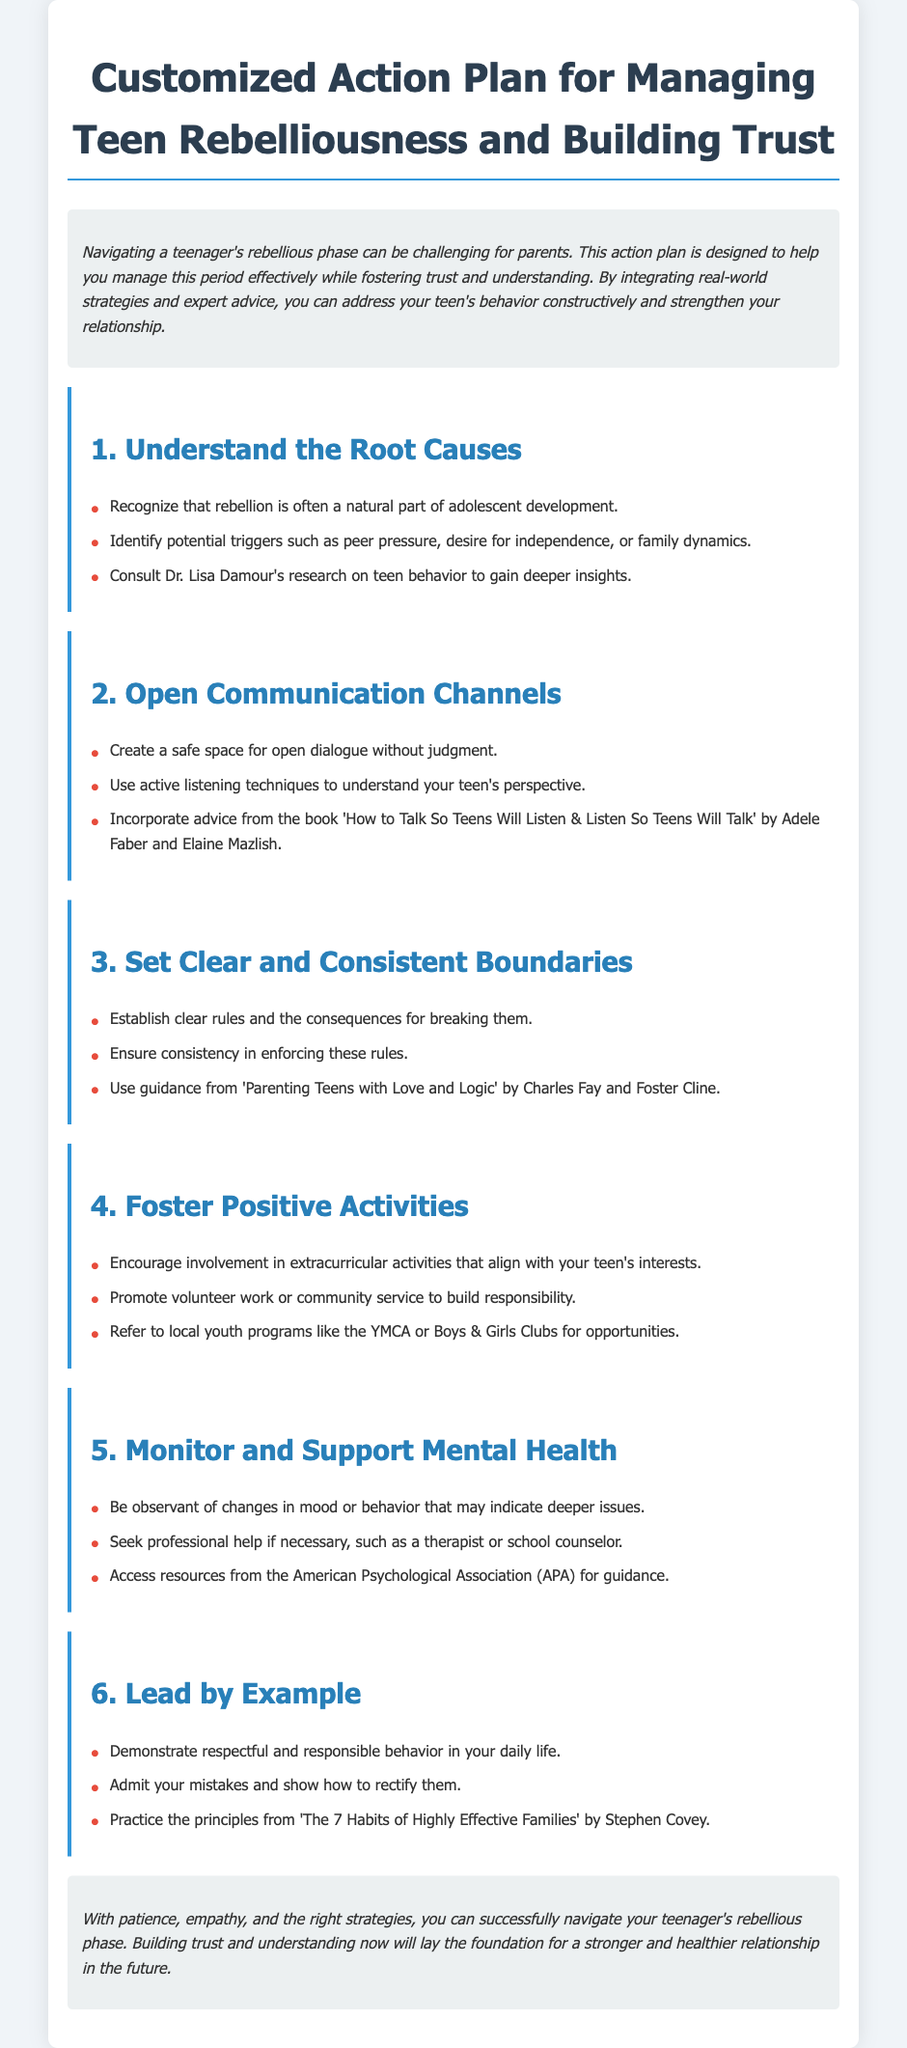What is the title of the document? The title is the heading of the document, which clearly states the main focus of the content.
Answer: Customized Action Plan for Managing Teen Rebelliousness and Building Trust Who is referenced for insight into teen behavior? This question refers to a specific expert mentioned in the document, noted for their research on adolescence.
Answer: Dr. Lisa Damour What is a suggested book for improving communication with teens? This question points to a specific resource recommended for parents to enhance their communication skills with teenagers.
Answer: How to Talk So Teens Will Listen & Listen So Teens Will Talk How many main sections are in the action plan? The total number of sections is derived from counting the major headings in the document.
Answer: Six What is one suggested activity to build responsibility? This question highlights an activity mentioned in the document that can aid in developing a sense of responsibility in teenagers.
Answer: Community service What principle should parents practice according to Stephen Covey? This question looks for specific advice from a well-known author referenced in the document regarding family effectiveness.
Answer: The 7 Habits of Highly Effective Families What organization is suggested for youth programs? The answer involves identifying a specific organization that offers opportunities for teenagers to engage positively.
Answer: YMCA What should parents observe to support mental health? This question extracts information concerning parental awareness related to their teen's behavior.
Answer: Changes in mood or behavior 